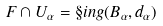<formula> <loc_0><loc_0><loc_500><loc_500>F \cap U _ { \alpha } = \S i n g ( B _ { \alpha } , d _ { \alpha } )</formula> 